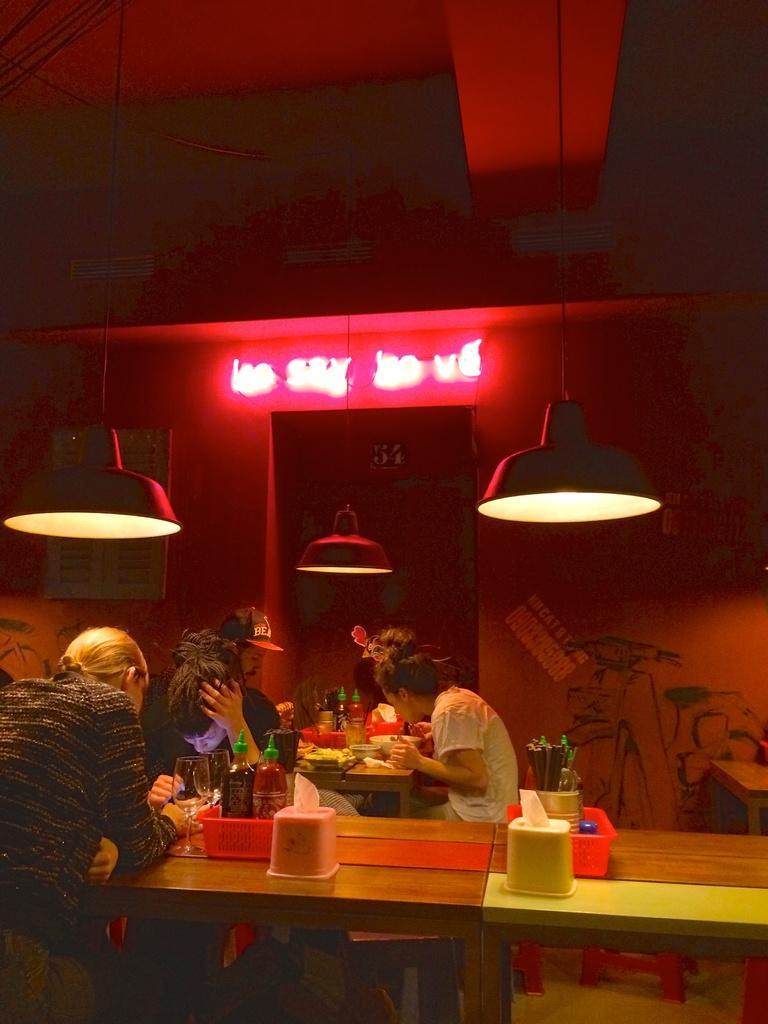Please provide a concise description of this image. In this image there are group of persons having their food and drinks 